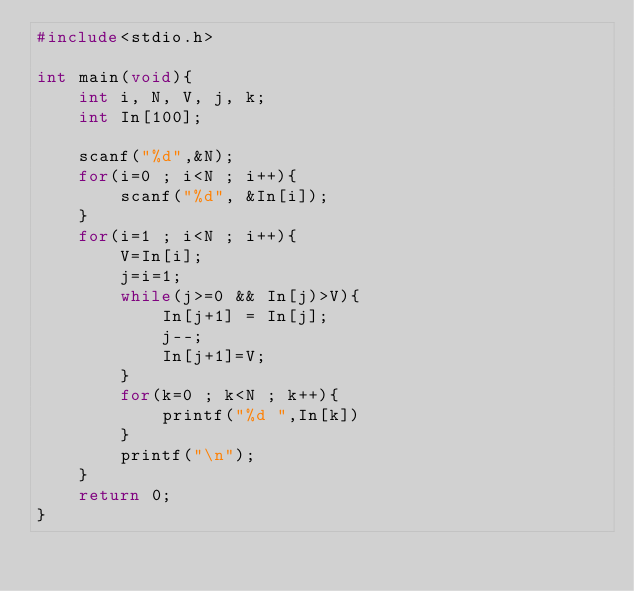Convert code to text. <code><loc_0><loc_0><loc_500><loc_500><_C_>#include<stdio.h>

int main(void){
    int i, N, V, j, k;
    int In[100];
    
    scanf("%d",&N);
    for(i=0 ; i<N ; i++){
        scanf("%d", &In[i]);
    }
    for(i=1 ; i<N ; i++){
        V=In[i];
        j=i=1;
        while(j>=0 && In[j)>V){
            In[j+1] = In[j];
            j--;
            In[j+1]=V;
        }
        for(k=0 ; k<N ; k++){
            printf("%d ",In[k])
        }
        printf("\n");
    }
    return 0;
}

</code> 